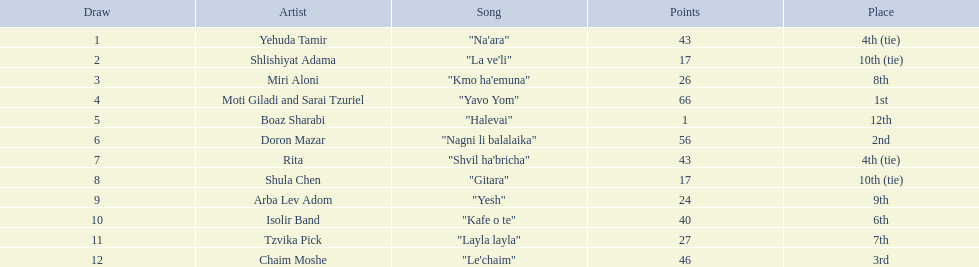What are the points in the competition? 43, 17, 26, 66, 1, 56, 43, 17, 24, 40, 27, 46. What is the lowest points? 1. What artist received these points? Boaz Sharabi. Could you parse the entire table? {'header': ['Draw', 'Artist', 'Song', 'Points', 'Place'], 'rows': [['1', 'Yehuda Tamir', '"Na\'ara"', '43', '4th (tie)'], ['2', 'Shlishiyat Adama', '"La ve\'li"', '17', '10th (tie)'], ['3', 'Miri Aloni', '"Kmo ha\'emuna"', '26', '8th'], ['4', 'Moti Giladi and Sarai Tzuriel', '"Yavo Yom"', '66', '1st'], ['5', 'Boaz Sharabi', '"Halevai"', '1', '12th'], ['6', 'Doron Mazar', '"Nagni li balalaika"', '56', '2nd'], ['7', 'Rita', '"Shvil ha\'bricha"', '43', '4th (tie)'], ['8', 'Shula Chen', '"Gitara"', '17', '10th (tie)'], ['9', 'Arba Lev Adom', '"Yesh"', '24', '9th'], ['10', 'Isolir Band', '"Kafe o te"', '40', '6th'], ['11', 'Tzvika Pick', '"Layla layla"', '27', '7th'], ['12', 'Chaim Moshe', '"Le\'chaim"', '46', '3rd']]} 